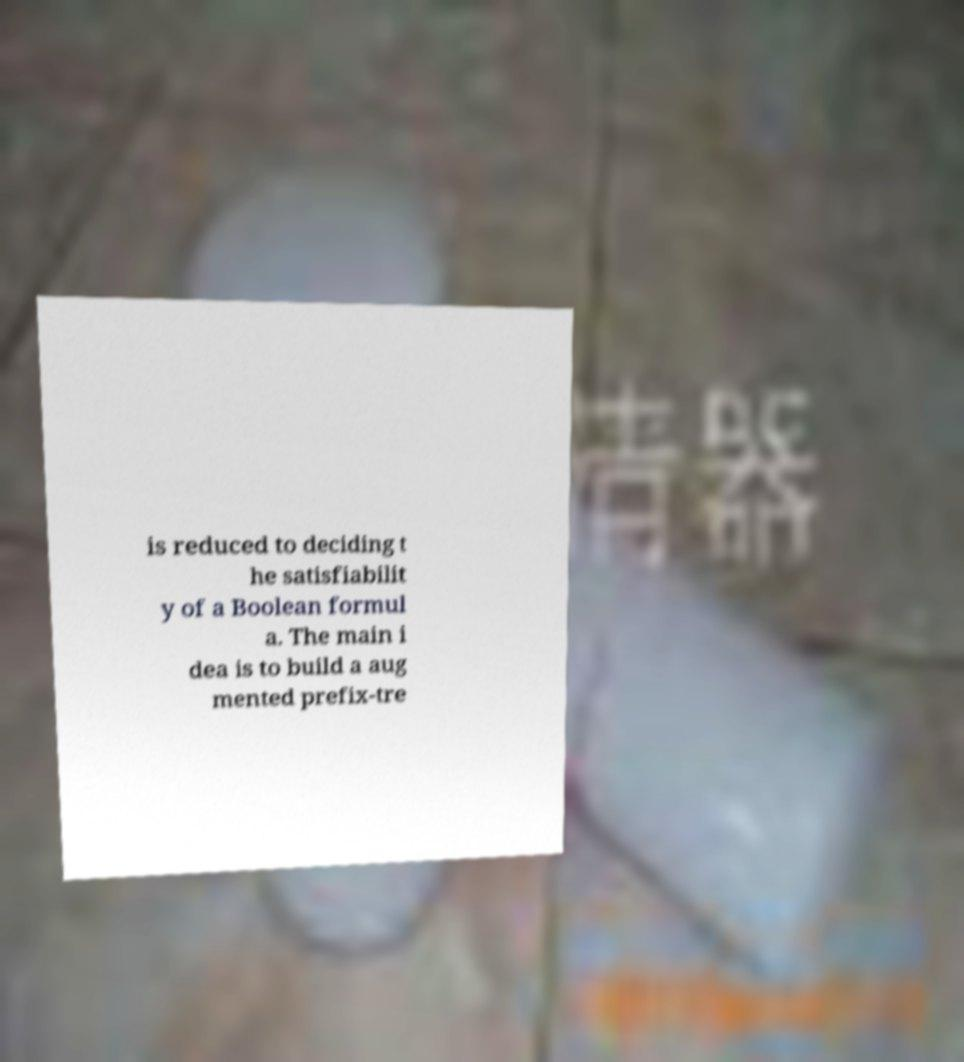Can you accurately transcribe the text from the provided image for me? is reduced to deciding t he satisfiabilit y of a Boolean formul a. The main i dea is to build a aug mented prefix-tre 